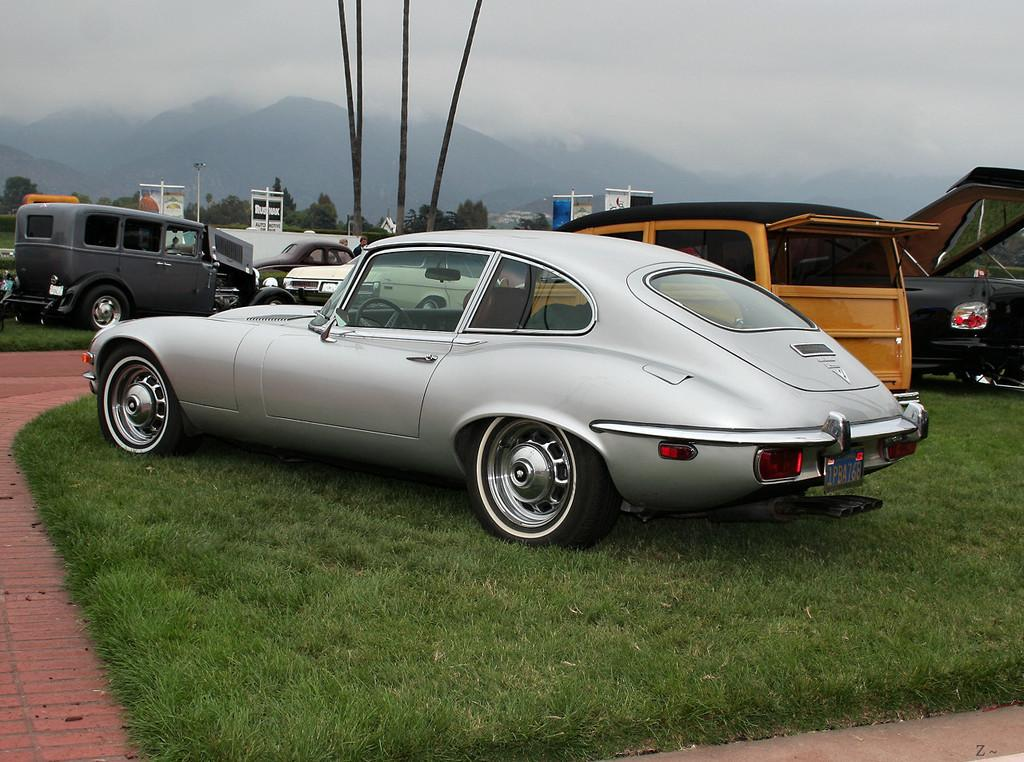What can be seen in the image? There are vehicles in the image. Can you describe the color of the front vehicle? The front vehicle is silver in color. What is visible in the background of the image? There are trees, a light pole, and mountains visible in the background of the image. What color are the trees in the background? The trees are green in color. How would you describe the sky in the image? The sky is white in color. What type of banana is hanging from the light pole in the image? There is no banana present in the image, and therefore no such activity can be observed. 